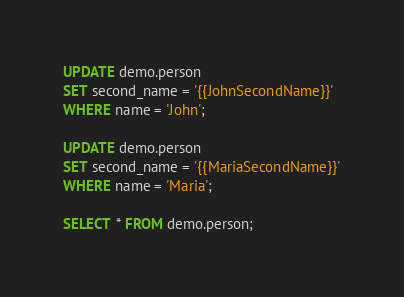Convert code to text. <code><loc_0><loc_0><loc_500><loc_500><_SQL_>UPDATE demo.person
SET second_name = '{{JohnSecondName}}'
WHERE name = 'John';

UPDATE demo.person
SET second_name = '{{MariaSecondName}}'
WHERE name = 'Maria';

SELECT * FROM demo.person;</code> 